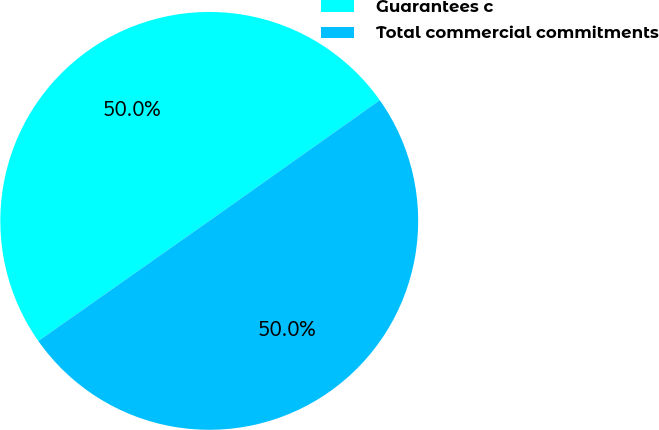<chart> <loc_0><loc_0><loc_500><loc_500><pie_chart><fcel>Guarantees c<fcel>Total commercial commitments<nl><fcel>49.95%<fcel>50.05%<nl></chart> 